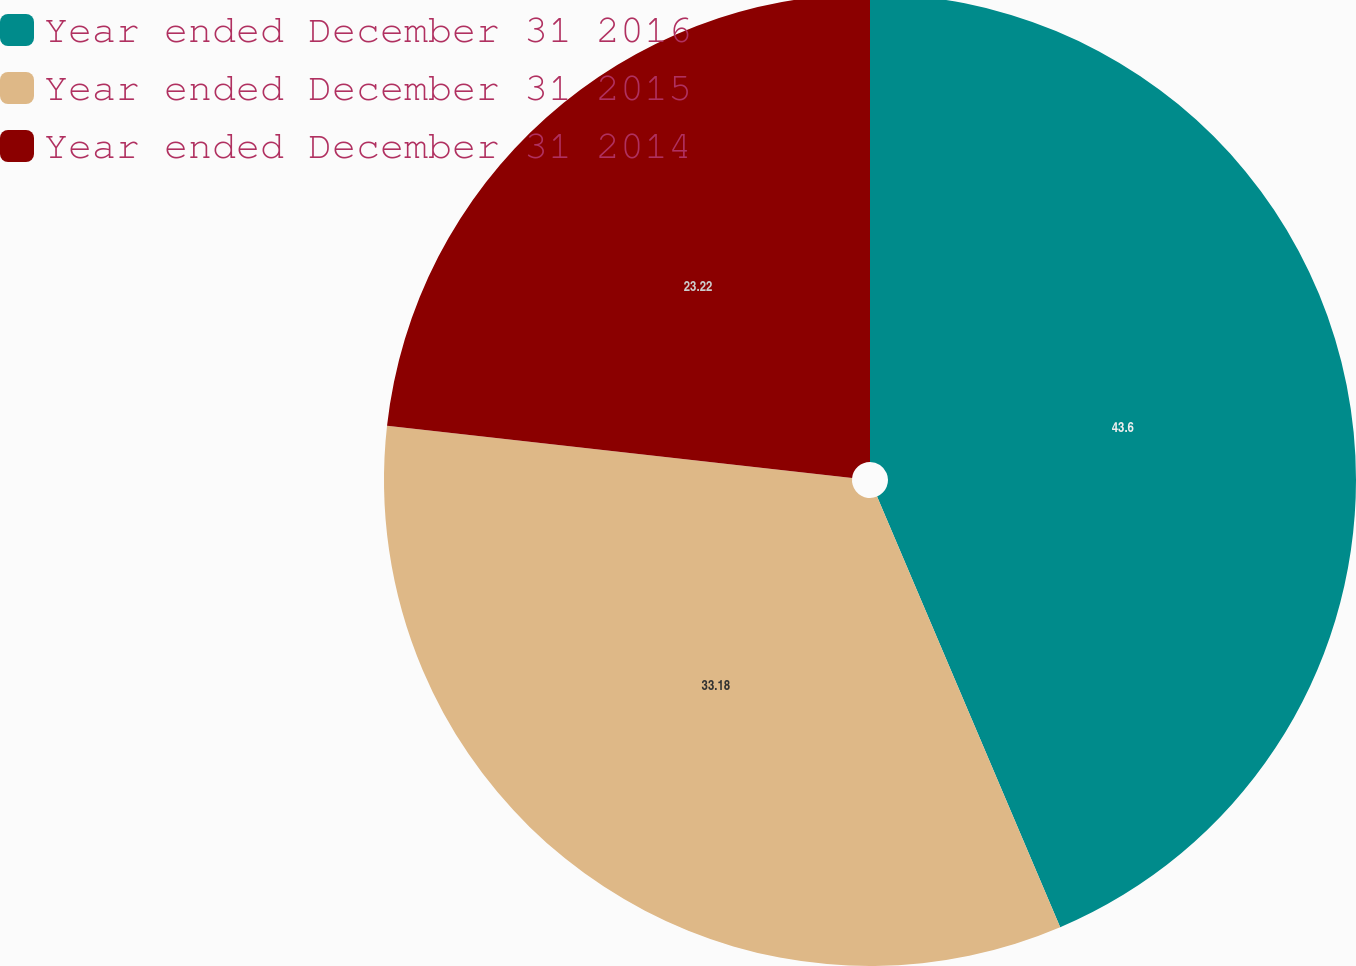Convert chart to OTSL. <chart><loc_0><loc_0><loc_500><loc_500><pie_chart><fcel>Year ended December 31 2016<fcel>Year ended December 31 2015<fcel>Year ended December 31 2014<nl><fcel>43.6%<fcel>33.18%<fcel>23.22%<nl></chart> 